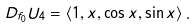Convert formula to latex. <formula><loc_0><loc_0><loc_500><loc_500>D _ { f _ { 0 } } U _ { 4 } = \left \langle 1 , x , \cos x , \sin x \right \rangle .</formula> 